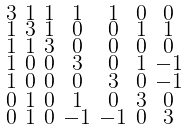Convert formula to latex. <formula><loc_0><loc_0><loc_500><loc_500>\begin{smallmatrix} 3 & 1 & 1 & 1 & 1 & 0 & 0 \\ 1 & 3 & 1 & 0 & 0 & 1 & 1 \\ 1 & 1 & 3 & 0 & 0 & 0 & 0 \\ 1 & 0 & 0 & 3 & 0 & 1 & - 1 \\ 1 & 0 & 0 & 0 & 3 & 0 & - 1 \\ 0 & 1 & 0 & 1 & 0 & 3 & 0 \\ 0 & 1 & 0 & - 1 & - 1 & 0 & 3 \end{smallmatrix}</formula> 